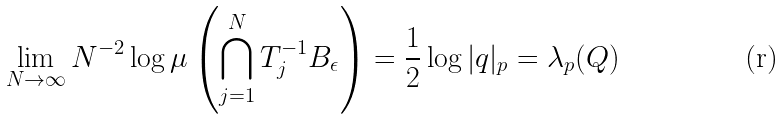<formula> <loc_0><loc_0><loc_500><loc_500>\lim _ { N \to \infty } N ^ { - 2 } \log \mu \left ( \bigcap _ { j = 1 } ^ { N } T _ { j } ^ { - 1 } B _ { \epsilon } \right ) = \frac { 1 } { 2 } \log | q | _ { p } = \lambda _ { p } ( Q )</formula> 